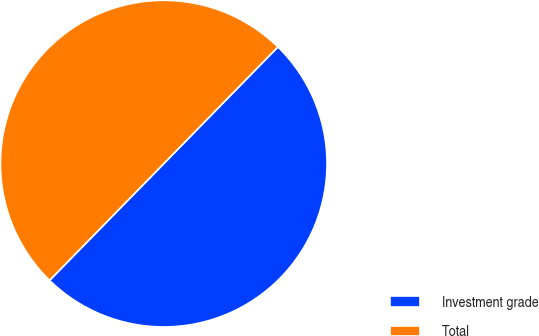<chart> <loc_0><loc_0><loc_500><loc_500><pie_chart><fcel>Investment grade<fcel>Total<nl><fcel>50.0%<fcel>50.0%<nl></chart> 